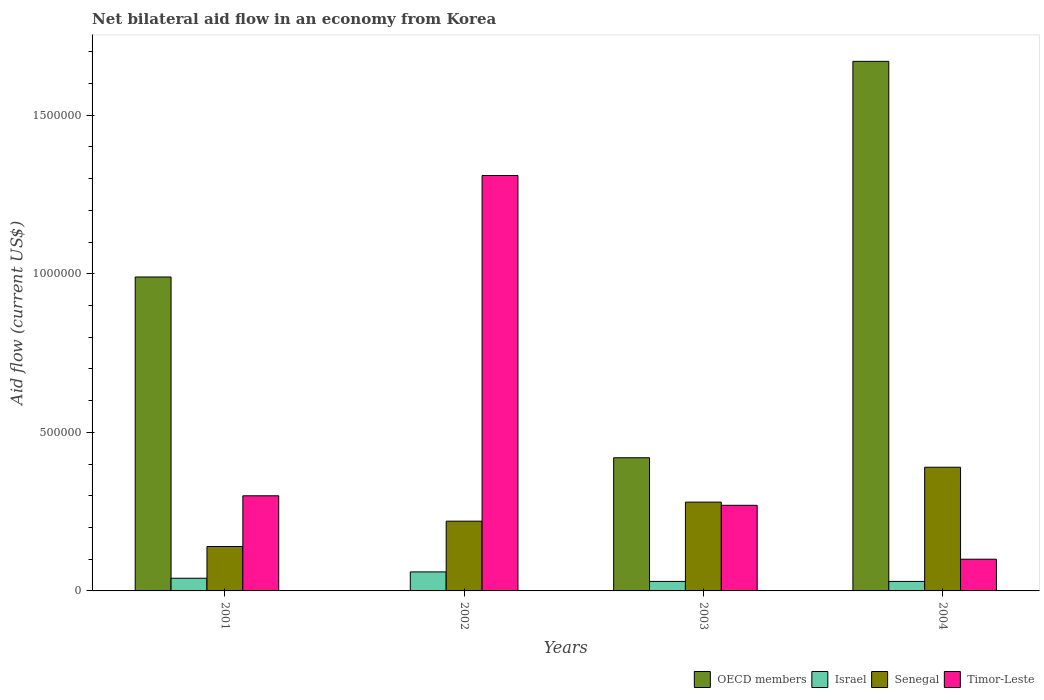Are the number of bars on each tick of the X-axis equal?
Your answer should be compact. No. How many bars are there on the 3rd tick from the right?
Keep it short and to the point. 3. In how many cases, is the number of bars for a given year not equal to the number of legend labels?
Provide a short and direct response. 1. What is the net bilateral aid flow in Israel in 2004?
Your answer should be very brief. 3.00e+04. In which year was the net bilateral aid flow in OECD members maximum?
Provide a succinct answer. 2004. What is the total net bilateral aid flow in OECD members in the graph?
Keep it short and to the point. 3.08e+06. What is the difference between the net bilateral aid flow in Timor-Leste in 2002 and that in 2004?
Your answer should be compact. 1.21e+06. What is the difference between the net bilateral aid flow in Timor-Leste in 2003 and the net bilateral aid flow in Israel in 2002?
Your answer should be very brief. 2.10e+05. What is the average net bilateral aid flow in Timor-Leste per year?
Make the answer very short. 4.95e+05. In the year 2001, what is the difference between the net bilateral aid flow in OECD members and net bilateral aid flow in Timor-Leste?
Offer a very short reply. 6.90e+05. What is the ratio of the net bilateral aid flow in Timor-Leste in 2002 to that in 2003?
Your response must be concise. 4.85. Is the net bilateral aid flow in Timor-Leste in 2001 less than that in 2003?
Offer a very short reply. No. Is the difference between the net bilateral aid flow in OECD members in 2001 and 2003 greater than the difference between the net bilateral aid flow in Timor-Leste in 2001 and 2003?
Ensure brevity in your answer.  Yes. What is the difference between the highest and the lowest net bilateral aid flow in OECD members?
Offer a terse response. 1.67e+06. Is the sum of the net bilateral aid flow in Israel in 2003 and 2004 greater than the maximum net bilateral aid flow in OECD members across all years?
Your answer should be very brief. No. How many bars are there?
Keep it short and to the point. 15. How many years are there in the graph?
Make the answer very short. 4. What is the difference between two consecutive major ticks on the Y-axis?
Offer a very short reply. 5.00e+05. Are the values on the major ticks of Y-axis written in scientific E-notation?
Make the answer very short. No. Does the graph contain any zero values?
Your answer should be very brief. Yes. Does the graph contain grids?
Your answer should be very brief. No. Where does the legend appear in the graph?
Offer a terse response. Bottom right. How are the legend labels stacked?
Ensure brevity in your answer.  Horizontal. What is the title of the graph?
Give a very brief answer. Net bilateral aid flow in an economy from Korea. Does "Niger" appear as one of the legend labels in the graph?
Ensure brevity in your answer.  No. What is the Aid flow (current US$) in OECD members in 2001?
Provide a short and direct response. 9.90e+05. What is the Aid flow (current US$) in Senegal in 2001?
Offer a terse response. 1.40e+05. What is the Aid flow (current US$) of Timor-Leste in 2001?
Offer a very short reply. 3.00e+05. What is the Aid flow (current US$) of Israel in 2002?
Provide a short and direct response. 6.00e+04. What is the Aid flow (current US$) of Timor-Leste in 2002?
Offer a very short reply. 1.31e+06. What is the Aid flow (current US$) in Senegal in 2003?
Provide a short and direct response. 2.80e+05. What is the Aid flow (current US$) in OECD members in 2004?
Ensure brevity in your answer.  1.67e+06. What is the Aid flow (current US$) of Israel in 2004?
Your answer should be very brief. 3.00e+04. What is the Aid flow (current US$) in Timor-Leste in 2004?
Your answer should be compact. 1.00e+05. Across all years, what is the maximum Aid flow (current US$) of OECD members?
Ensure brevity in your answer.  1.67e+06. Across all years, what is the maximum Aid flow (current US$) of Israel?
Your answer should be very brief. 6.00e+04. Across all years, what is the maximum Aid flow (current US$) in Timor-Leste?
Your answer should be compact. 1.31e+06. Across all years, what is the minimum Aid flow (current US$) in Senegal?
Your answer should be very brief. 1.40e+05. What is the total Aid flow (current US$) in OECD members in the graph?
Offer a terse response. 3.08e+06. What is the total Aid flow (current US$) of Israel in the graph?
Give a very brief answer. 1.60e+05. What is the total Aid flow (current US$) in Senegal in the graph?
Provide a short and direct response. 1.03e+06. What is the total Aid flow (current US$) of Timor-Leste in the graph?
Offer a terse response. 1.98e+06. What is the difference between the Aid flow (current US$) in Israel in 2001 and that in 2002?
Your answer should be very brief. -2.00e+04. What is the difference between the Aid flow (current US$) of Senegal in 2001 and that in 2002?
Ensure brevity in your answer.  -8.00e+04. What is the difference between the Aid flow (current US$) in Timor-Leste in 2001 and that in 2002?
Offer a terse response. -1.01e+06. What is the difference between the Aid flow (current US$) of OECD members in 2001 and that in 2003?
Ensure brevity in your answer.  5.70e+05. What is the difference between the Aid flow (current US$) of Israel in 2001 and that in 2003?
Your answer should be very brief. 10000. What is the difference between the Aid flow (current US$) in Senegal in 2001 and that in 2003?
Keep it short and to the point. -1.40e+05. What is the difference between the Aid flow (current US$) in OECD members in 2001 and that in 2004?
Your answer should be very brief. -6.80e+05. What is the difference between the Aid flow (current US$) in Senegal in 2001 and that in 2004?
Your answer should be very brief. -2.50e+05. What is the difference between the Aid flow (current US$) of Timor-Leste in 2001 and that in 2004?
Your response must be concise. 2.00e+05. What is the difference between the Aid flow (current US$) of Timor-Leste in 2002 and that in 2003?
Keep it short and to the point. 1.04e+06. What is the difference between the Aid flow (current US$) in Senegal in 2002 and that in 2004?
Your response must be concise. -1.70e+05. What is the difference between the Aid flow (current US$) of Timor-Leste in 2002 and that in 2004?
Your answer should be very brief. 1.21e+06. What is the difference between the Aid flow (current US$) in OECD members in 2003 and that in 2004?
Offer a very short reply. -1.25e+06. What is the difference between the Aid flow (current US$) of Israel in 2003 and that in 2004?
Offer a terse response. 0. What is the difference between the Aid flow (current US$) of OECD members in 2001 and the Aid flow (current US$) of Israel in 2002?
Provide a short and direct response. 9.30e+05. What is the difference between the Aid flow (current US$) of OECD members in 2001 and the Aid flow (current US$) of Senegal in 2002?
Provide a short and direct response. 7.70e+05. What is the difference between the Aid flow (current US$) of OECD members in 2001 and the Aid flow (current US$) of Timor-Leste in 2002?
Make the answer very short. -3.20e+05. What is the difference between the Aid flow (current US$) in Israel in 2001 and the Aid flow (current US$) in Timor-Leste in 2002?
Offer a very short reply. -1.27e+06. What is the difference between the Aid flow (current US$) of Senegal in 2001 and the Aid flow (current US$) of Timor-Leste in 2002?
Your answer should be very brief. -1.17e+06. What is the difference between the Aid flow (current US$) of OECD members in 2001 and the Aid flow (current US$) of Israel in 2003?
Your answer should be compact. 9.60e+05. What is the difference between the Aid flow (current US$) in OECD members in 2001 and the Aid flow (current US$) in Senegal in 2003?
Your response must be concise. 7.10e+05. What is the difference between the Aid flow (current US$) in OECD members in 2001 and the Aid flow (current US$) in Timor-Leste in 2003?
Offer a very short reply. 7.20e+05. What is the difference between the Aid flow (current US$) in Israel in 2001 and the Aid flow (current US$) in Timor-Leste in 2003?
Give a very brief answer. -2.30e+05. What is the difference between the Aid flow (current US$) in Senegal in 2001 and the Aid flow (current US$) in Timor-Leste in 2003?
Provide a succinct answer. -1.30e+05. What is the difference between the Aid flow (current US$) in OECD members in 2001 and the Aid flow (current US$) in Israel in 2004?
Offer a terse response. 9.60e+05. What is the difference between the Aid flow (current US$) of OECD members in 2001 and the Aid flow (current US$) of Timor-Leste in 2004?
Give a very brief answer. 8.90e+05. What is the difference between the Aid flow (current US$) of Israel in 2001 and the Aid flow (current US$) of Senegal in 2004?
Your answer should be very brief. -3.50e+05. What is the difference between the Aid flow (current US$) in Israel in 2001 and the Aid flow (current US$) in Timor-Leste in 2004?
Make the answer very short. -6.00e+04. What is the difference between the Aid flow (current US$) in Israel in 2002 and the Aid flow (current US$) in Senegal in 2003?
Keep it short and to the point. -2.20e+05. What is the difference between the Aid flow (current US$) in Israel in 2002 and the Aid flow (current US$) in Timor-Leste in 2003?
Make the answer very short. -2.10e+05. What is the difference between the Aid flow (current US$) of Israel in 2002 and the Aid flow (current US$) of Senegal in 2004?
Offer a very short reply. -3.30e+05. What is the difference between the Aid flow (current US$) in OECD members in 2003 and the Aid flow (current US$) in Senegal in 2004?
Offer a terse response. 3.00e+04. What is the difference between the Aid flow (current US$) of Israel in 2003 and the Aid flow (current US$) of Senegal in 2004?
Keep it short and to the point. -3.60e+05. What is the average Aid flow (current US$) of OECD members per year?
Offer a very short reply. 7.70e+05. What is the average Aid flow (current US$) of Senegal per year?
Your response must be concise. 2.58e+05. What is the average Aid flow (current US$) in Timor-Leste per year?
Your answer should be compact. 4.95e+05. In the year 2001, what is the difference between the Aid flow (current US$) of OECD members and Aid flow (current US$) of Israel?
Ensure brevity in your answer.  9.50e+05. In the year 2001, what is the difference between the Aid flow (current US$) in OECD members and Aid flow (current US$) in Senegal?
Your answer should be compact. 8.50e+05. In the year 2001, what is the difference between the Aid flow (current US$) of OECD members and Aid flow (current US$) of Timor-Leste?
Provide a succinct answer. 6.90e+05. In the year 2001, what is the difference between the Aid flow (current US$) in Israel and Aid flow (current US$) in Senegal?
Your response must be concise. -1.00e+05. In the year 2001, what is the difference between the Aid flow (current US$) in Israel and Aid flow (current US$) in Timor-Leste?
Your answer should be very brief. -2.60e+05. In the year 2001, what is the difference between the Aid flow (current US$) of Senegal and Aid flow (current US$) of Timor-Leste?
Provide a succinct answer. -1.60e+05. In the year 2002, what is the difference between the Aid flow (current US$) of Israel and Aid flow (current US$) of Timor-Leste?
Ensure brevity in your answer.  -1.25e+06. In the year 2002, what is the difference between the Aid flow (current US$) in Senegal and Aid flow (current US$) in Timor-Leste?
Offer a very short reply. -1.09e+06. In the year 2003, what is the difference between the Aid flow (current US$) in OECD members and Aid flow (current US$) in Israel?
Keep it short and to the point. 3.90e+05. In the year 2003, what is the difference between the Aid flow (current US$) of OECD members and Aid flow (current US$) of Senegal?
Provide a short and direct response. 1.40e+05. In the year 2003, what is the difference between the Aid flow (current US$) of Israel and Aid flow (current US$) of Senegal?
Make the answer very short. -2.50e+05. In the year 2003, what is the difference between the Aid flow (current US$) of Senegal and Aid flow (current US$) of Timor-Leste?
Give a very brief answer. 10000. In the year 2004, what is the difference between the Aid flow (current US$) in OECD members and Aid flow (current US$) in Israel?
Ensure brevity in your answer.  1.64e+06. In the year 2004, what is the difference between the Aid flow (current US$) of OECD members and Aid flow (current US$) of Senegal?
Make the answer very short. 1.28e+06. In the year 2004, what is the difference between the Aid flow (current US$) in OECD members and Aid flow (current US$) in Timor-Leste?
Your answer should be very brief. 1.57e+06. In the year 2004, what is the difference between the Aid flow (current US$) in Israel and Aid flow (current US$) in Senegal?
Make the answer very short. -3.60e+05. In the year 2004, what is the difference between the Aid flow (current US$) of Israel and Aid flow (current US$) of Timor-Leste?
Your answer should be very brief. -7.00e+04. In the year 2004, what is the difference between the Aid flow (current US$) in Senegal and Aid flow (current US$) in Timor-Leste?
Offer a very short reply. 2.90e+05. What is the ratio of the Aid flow (current US$) of Israel in 2001 to that in 2002?
Your answer should be very brief. 0.67. What is the ratio of the Aid flow (current US$) in Senegal in 2001 to that in 2002?
Offer a terse response. 0.64. What is the ratio of the Aid flow (current US$) of Timor-Leste in 2001 to that in 2002?
Offer a very short reply. 0.23. What is the ratio of the Aid flow (current US$) of OECD members in 2001 to that in 2003?
Keep it short and to the point. 2.36. What is the ratio of the Aid flow (current US$) in Israel in 2001 to that in 2003?
Your answer should be compact. 1.33. What is the ratio of the Aid flow (current US$) in Senegal in 2001 to that in 2003?
Offer a very short reply. 0.5. What is the ratio of the Aid flow (current US$) of OECD members in 2001 to that in 2004?
Offer a very short reply. 0.59. What is the ratio of the Aid flow (current US$) of Senegal in 2001 to that in 2004?
Keep it short and to the point. 0.36. What is the ratio of the Aid flow (current US$) of Senegal in 2002 to that in 2003?
Give a very brief answer. 0.79. What is the ratio of the Aid flow (current US$) in Timor-Leste in 2002 to that in 2003?
Provide a short and direct response. 4.85. What is the ratio of the Aid flow (current US$) in Israel in 2002 to that in 2004?
Your answer should be very brief. 2. What is the ratio of the Aid flow (current US$) in Senegal in 2002 to that in 2004?
Offer a terse response. 0.56. What is the ratio of the Aid flow (current US$) of Timor-Leste in 2002 to that in 2004?
Make the answer very short. 13.1. What is the ratio of the Aid flow (current US$) in OECD members in 2003 to that in 2004?
Offer a terse response. 0.25. What is the ratio of the Aid flow (current US$) of Israel in 2003 to that in 2004?
Make the answer very short. 1. What is the ratio of the Aid flow (current US$) in Senegal in 2003 to that in 2004?
Offer a very short reply. 0.72. What is the difference between the highest and the second highest Aid flow (current US$) in OECD members?
Ensure brevity in your answer.  6.80e+05. What is the difference between the highest and the second highest Aid flow (current US$) of Israel?
Offer a very short reply. 2.00e+04. What is the difference between the highest and the second highest Aid flow (current US$) of Senegal?
Your response must be concise. 1.10e+05. What is the difference between the highest and the second highest Aid flow (current US$) of Timor-Leste?
Your response must be concise. 1.01e+06. What is the difference between the highest and the lowest Aid flow (current US$) in OECD members?
Your response must be concise. 1.67e+06. What is the difference between the highest and the lowest Aid flow (current US$) in Timor-Leste?
Offer a terse response. 1.21e+06. 